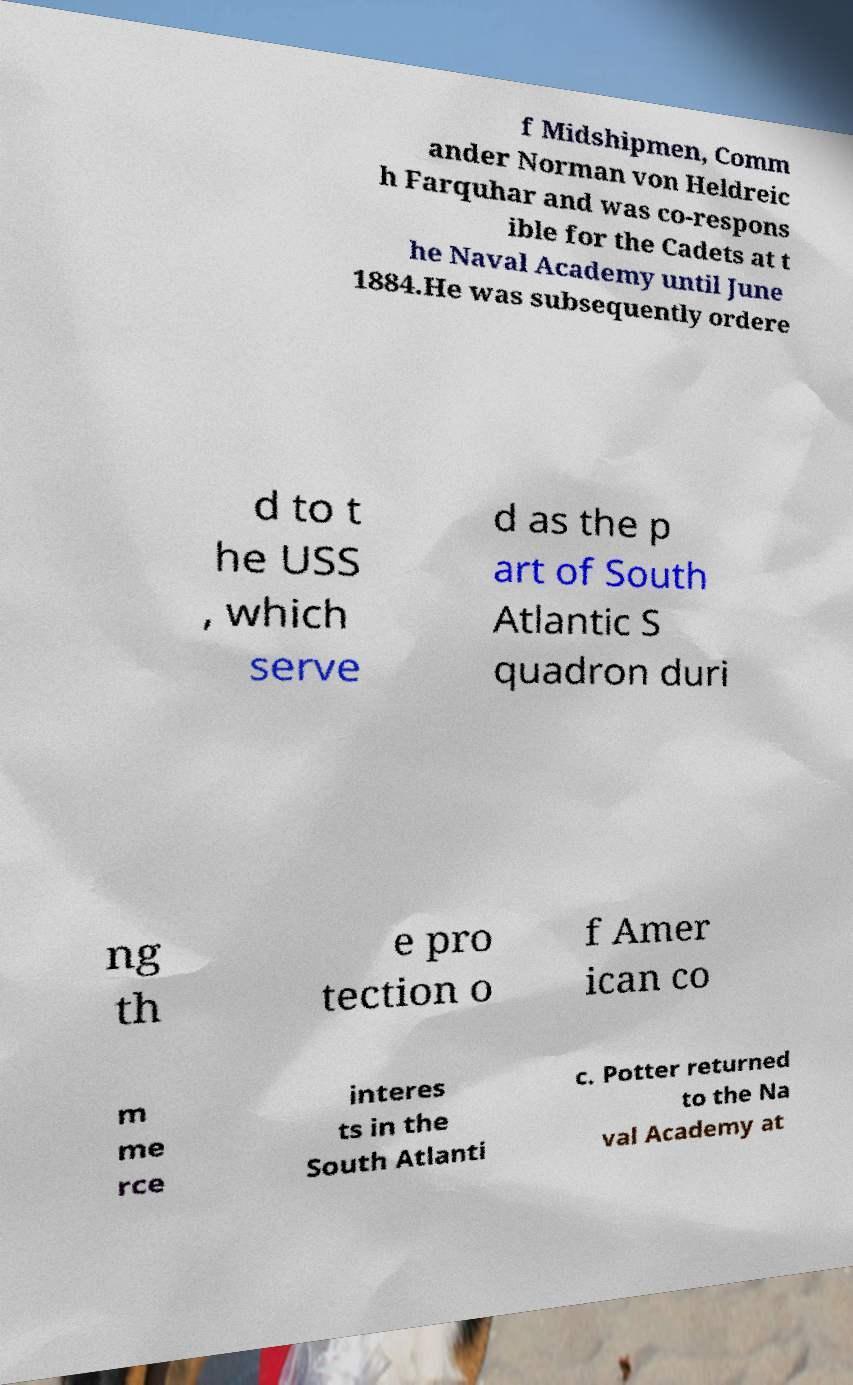For documentation purposes, I need the text within this image transcribed. Could you provide that? f Midshipmen, Comm ander Norman von Heldreic h Farquhar and was co-respons ible for the Cadets at t he Naval Academy until June 1884.He was subsequently ordere d to t he USS , which serve d as the p art of South Atlantic S quadron duri ng th e pro tection o f Amer ican co m me rce interes ts in the South Atlanti c. Potter returned to the Na val Academy at 